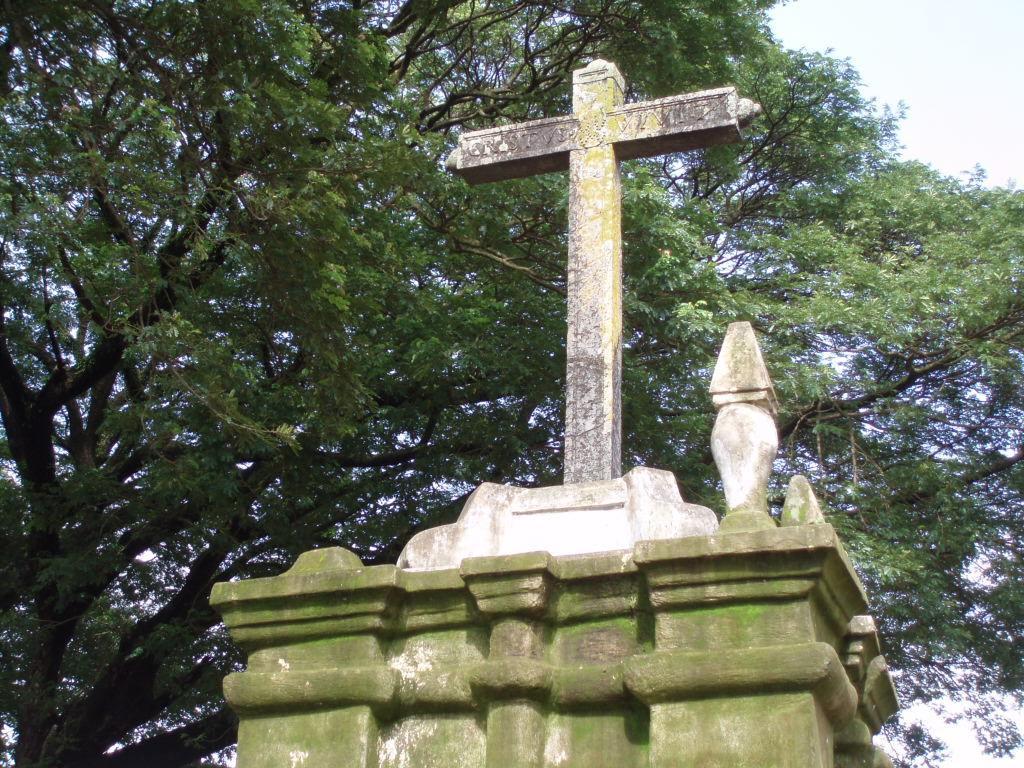Could you give a brief overview of what you see in this image? In this image there is a big pillow with cross symbol on the top, beside that there are trees. 